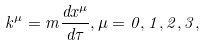Convert formula to latex. <formula><loc_0><loc_0><loc_500><loc_500>k ^ { \mu } = m \frac { d x ^ { \mu } } { d \tau } , \mu = 0 , 1 , 2 , 3 ,</formula> 